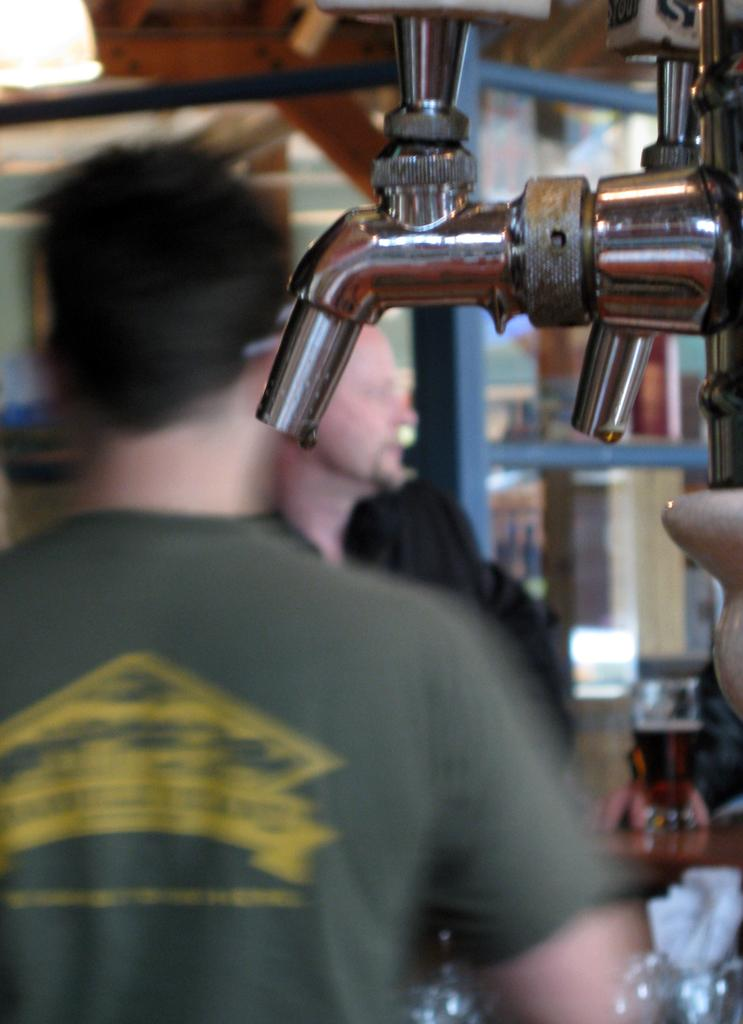What is the main object in the picture? There is a brewing machine in the picture. What are the people near the brewing machine doing? The facts do not specify what the people are doing, but they are standing near the brewing machine. What type of nail is being used to hang a painting on the wall in the image? There is no painting or nail present in the image; it only features a brewing machine and people standing nearby. 